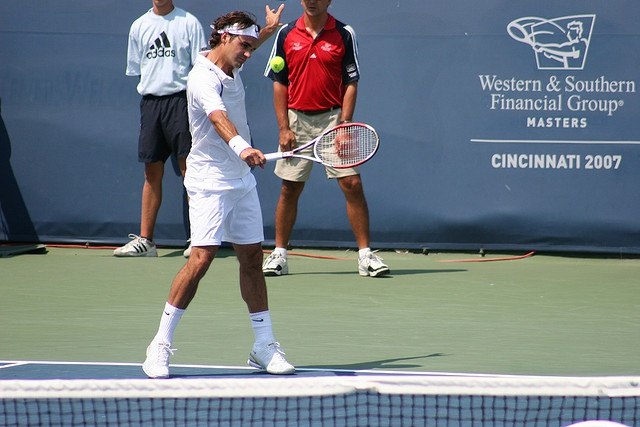Describe the objects in this image and their specific colors. I can see people in blue, white, darkgray, and black tones, people in blue, maroon, black, gray, and brown tones, people in blue, black, lavender, darkgray, and maroon tones, tennis racket in blue, darkgray, white, gray, and lightpink tones, and sports ball in blue, yellow, khaki, green, and lightgreen tones in this image. 